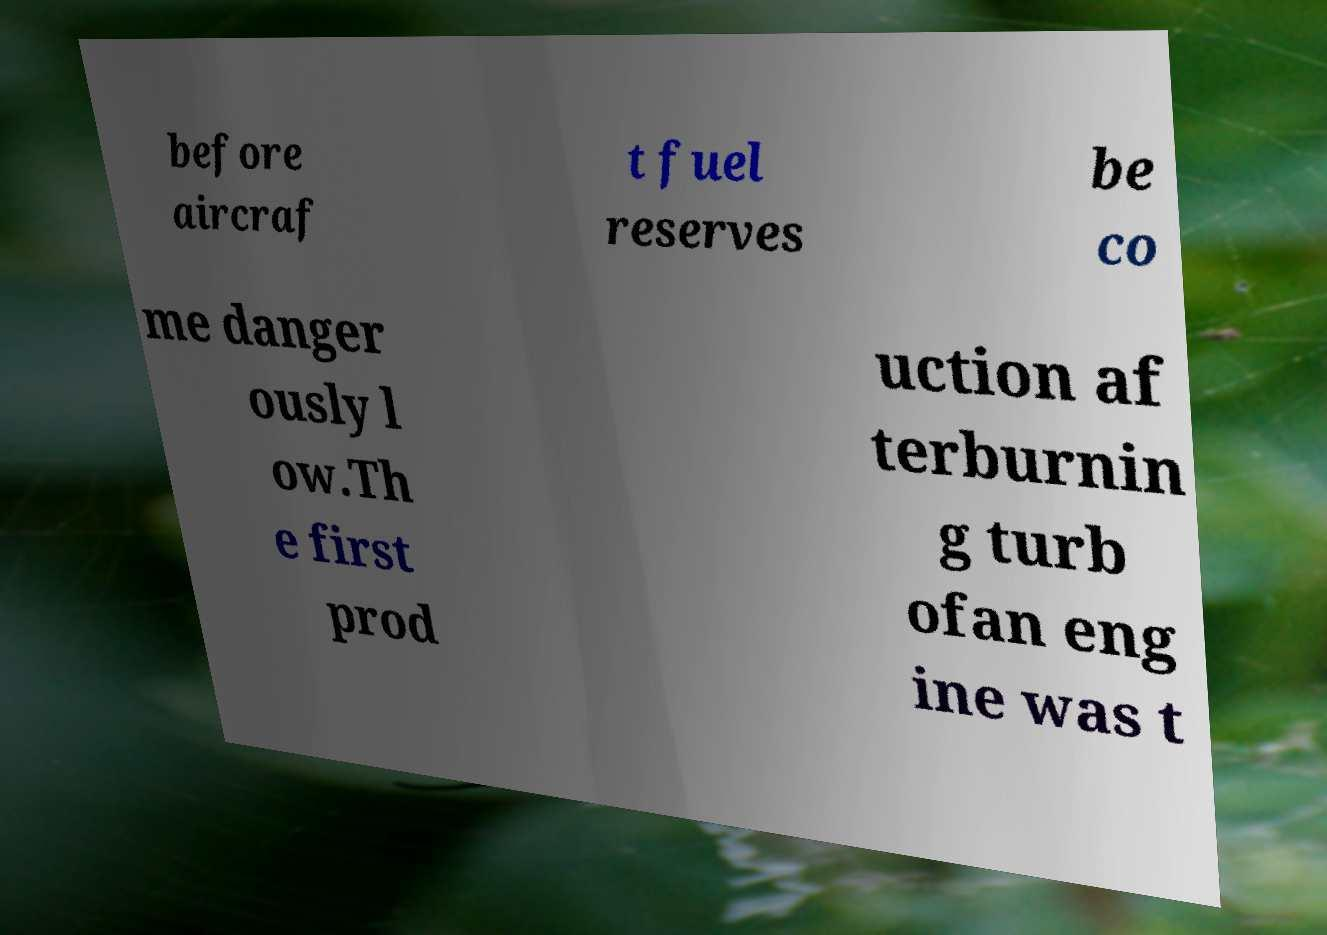Can you read and provide the text displayed in the image?This photo seems to have some interesting text. Can you extract and type it out for me? before aircraf t fuel reserves be co me danger ously l ow.Th e first prod uction af terburnin g turb ofan eng ine was t 